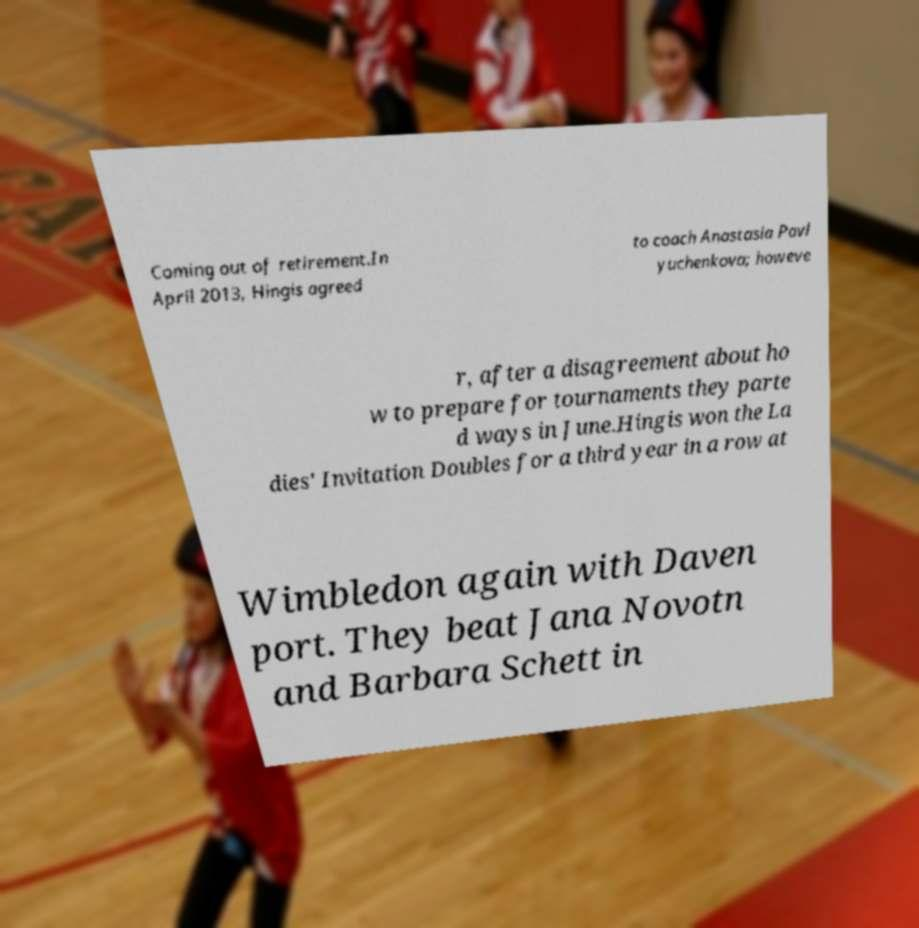Can you read and provide the text displayed in the image?This photo seems to have some interesting text. Can you extract and type it out for me? Coming out of retirement.In April 2013, Hingis agreed to coach Anastasia Pavl yuchenkova; howeve r, after a disagreement about ho w to prepare for tournaments they parte d ways in June.Hingis won the La dies' Invitation Doubles for a third year in a row at Wimbledon again with Daven port. They beat Jana Novotn and Barbara Schett in 